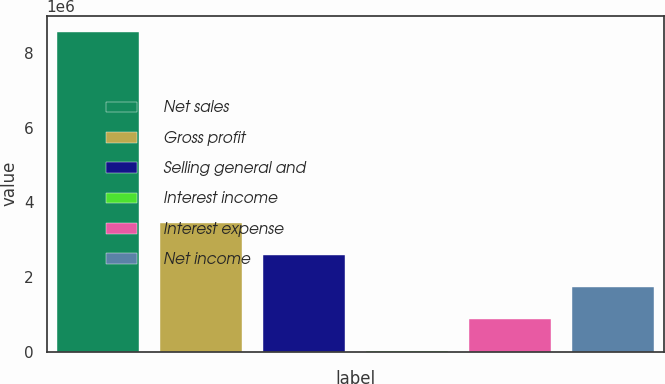<chart> <loc_0><loc_0><loc_500><loc_500><bar_chart><fcel>Net sales<fcel>Gross profit<fcel>Selling general and<fcel>Interest income<fcel>Interest expense<fcel>Net income<nl><fcel>8.58224e+06<fcel>3.4383e+06<fcel>2.58097e+06<fcel>9001<fcel>866325<fcel>1.72365e+06<nl></chart> 